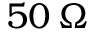<formula> <loc_0><loc_0><loc_500><loc_500>5 0 \, \Omega</formula> 